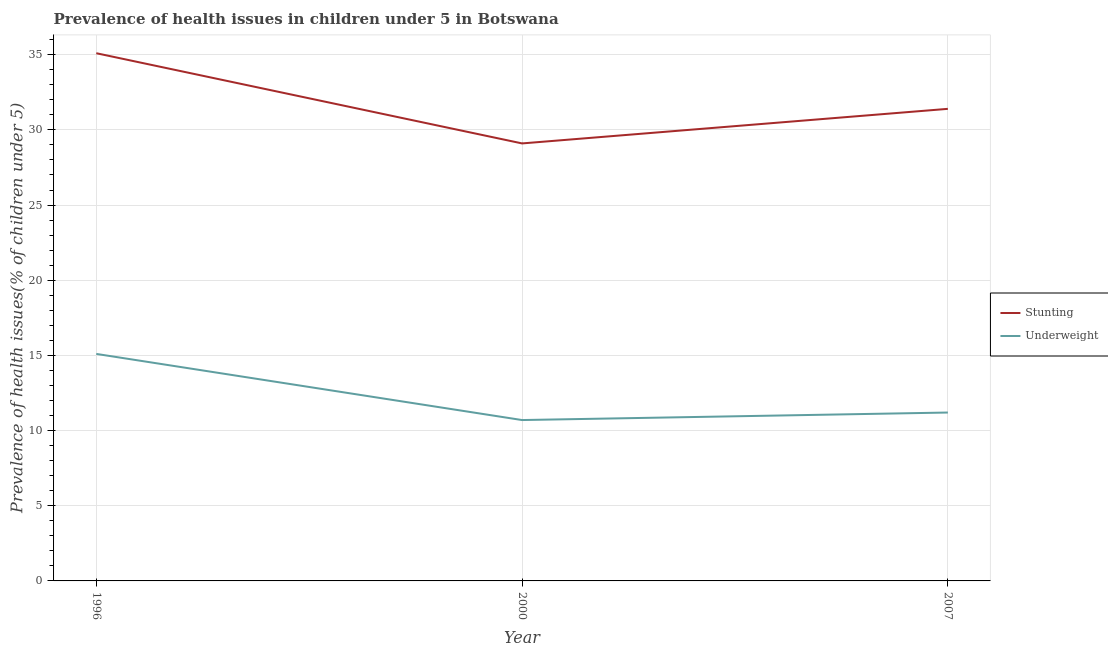Does the line corresponding to percentage of stunted children intersect with the line corresponding to percentage of underweight children?
Provide a succinct answer. No. Is the number of lines equal to the number of legend labels?
Offer a very short reply. Yes. What is the percentage of stunted children in 2007?
Ensure brevity in your answer.  31.4. Across all years, what is the maximum percentage of underweight children?
Keep it short and to the point. 15.1. Across all years, what is the minimum percentage of stunted children?
Give a very brief answer. 29.1. In which year was the percentage of stunted children minimum?
Provide a succinct answer. 2000. What is the total percentage of underweight children in the graph?
Give a very brief answer. 37. What is the difference between the percentage of underweight children in 1996 and that in 2007?
Offer a very short reply. 3.9. What is the difference between the percentage of stunted children in 2007 and the percentage of underweight children in 2000?
Ensure brevity in your answer.  20.7. What is the average percentage of underweight children per year?
Provide a short and direct response. 12.33. In the year 2007, what is the difference between the percentage of stunted children and percentage of underweight children?
Ensure brevity in your answer.  20.2. In how many years, is the percentage of stunted children greater than 2 %?
Offer a terse response. 3. What is the ratio of the percentage of stunted children in 2000 to that in 2007?
Provide a succinct answer. 0.93. Is the percentage of stunted children in 1996 less than that in 2000?
Provide a short and direct response. No. What is the difference between the highest and the second highest percentage of stunted children?
Provide a succinct answer. 3.7. What is the difference between the highest and the lowest percentage of underweight children?
Keep it short and to the point. 4.4. In how many years, is the percentage of stunted children greater than the average percentage of stunted children taken over all years?
Offer a terse response. 1. Is the sum of the percentage of stunted children in 1996 and 2000 greater than the maximum percentage of underweight children across all years?
Keep it short and to the point. Yes. Does the percentage of stunted children monotonically increase over the years?
Provide a short and direct response. No. Is the percentage of underweight children strictly greater than the percentage of stunted children over the years?
Your response must be concise. No. Are the values on the major ticks of Y-axis written in scientific E-notation?
Give a very brief answer. No. Does the graph contain grids?
Ensure brevity in your answer.  Yes. How many legend labels are there?
Offer a terse response. 2. What is the title of the graph?
Offer a terse response. Prevalence of health issues in children under 5 in Botswana. What is the label or title of the X-axis?
Provide a short and direct response. Year. What is the label or title of the Y-axis?
Your response must be concise. Prevalence of health issues(% of children under 5). What is the Prevalence of health issues(% of children under 5) in Stunting in 1996?
Ensure brevity in your answer.  35.1. What is the Prevalence of health issues(% of children under 5) of Underweight in 1996?
Ensure brevity in your answer.  15.1. What is the Prevalence of health issues(% of children under 5) in Stunting in 2000?
Keep it short and to the point. 29.1. What is the Prevalence of health issues(% of children under 5) in Underweight in 2000?
Give a very brief answer. 10.7. What is the Prevalence of health issues(% of children under 5) of Stunting in 2007?
Ensure brevity in your answer.  31.4. What is the Prevalence of health issues(% of children under 5) in Underweight in 2007?
Offer a terse response. 11.2. Across all years, what is the maximum Prevalence of health issues(% of children under 5) of Stunting?
Make the answer very short. 35.1. Across all years, what is the maximum Prevalence of health issues(% of children under 5) in Underweight?
Give a very brief answer. 15.1. Across all years, what is the minimum Prevalence of health issues(% of children under 5) of Stunting?
Give a very brief answer. 29.1. Across all years, what is the minimum Prevalence of health issues(% of children under 5) in Underweight?
Ensure brevity in your answer.  10.7. What is the total Prevalence of health issues(% of children under 5) in Stunting in the graph?
Offer a very short reply. 95.6. What is the difference between the Prevalence of health issues(% of children under 5) of Stunting in 1996 and that in 2000?
Your answer should be very brief. 6. What is the difference between the Prevalence of health issues(% of children under 5) in Underweight in 1996 and that in 2000?
Keep it short and to the point. 4.4. What is the difference between the Prevalence of health issues(% of children under 5) in Stunting in 1996 and that in 2007?
Ensure brevity in your answer.  3.7. What is the difference between the Prevalence of health issues(% of children under 5) in Underweight in 2000 and that in 2007?
Offer a very short reply. -0.5. What is the difference between the Prevalence of health issues(% of children under 5) of Stunting in 1996 and the Prevalence of health issues(% of children under 5) of Underweight in 2000?
Provide a short and direct response. 24.4. What is the difference between the Prevalence of health issues(% of children under 5) of Stunting in 1996 and the Prevalence of health issues(% of children under 5) of Underweight in 2007?
Offer a very short reply. 23.9. What is the difference between the Prevalence of health issues(% of children under 5) of Stunting in 2000 and the Prevalence of health issues(% of children under 5) of Underweight in 2007?
Your answer should be compact. 17.9. What is the average Prevalence of health issues(% of children under 5) of Stunting per year?
Make the answer very short. 31.87. What is the average Prevalence of health issues(% of children under 5) of Underweight per year?
Provide a succinct answer. 12.33. In the year 2000, what is the difference between the Prevalence of health issues(% of children under 5) in Stunting and Prevalence of health issues(% of children under 5) in Underweight?
Make the answer very short. 18.4. In the year 2007, what is the difference between the Prevalence of health issues(% of children under 5) in Stunting and Prevalence of health issues(% of children under 5) in Underweight?
Your response must be concise. 20.2. What is the ratio of the Prevalence of health issues(% of children under 5) in Stunting in 1996 to that in 2000?
Make the answer very short. 1.21. What is the ratio of the Prevalence of health issues(% of children under 5) in Underweight in 1996 to that in 2000?
Provide a short and direct response. 1.41. What is the ratio of the Prevalence of health issues(% of children under 5) in Stunting in 1996 to that in 2007?
Offer a very short reply. 1.12. What is the ratio of the Prevalence of health issues(% of children under 5) in Underweight in 1996 to that in 2007?
Make the answer very short. 1.35. What is the ratio of the Prevalence of health issues(% of children under 5) in Stunting in 2000 to that in 2007?
Keep it short and to the point. 0.93. What is the ratio of the Prevalence of health issues(% of children under 5) of Underweight in 2000 to that in 2007?
Give a very brief answer. 0.96. What is the difference between the highest and the lowest Prevalence of health issues(% of children under 5) in Stunting?
Offer a terse response. 6. What is the difference between the highest and the lowest Prevalence of health issues(% of children under 5) in Underweight?
Ensure brevity in your answer.  4.4. 